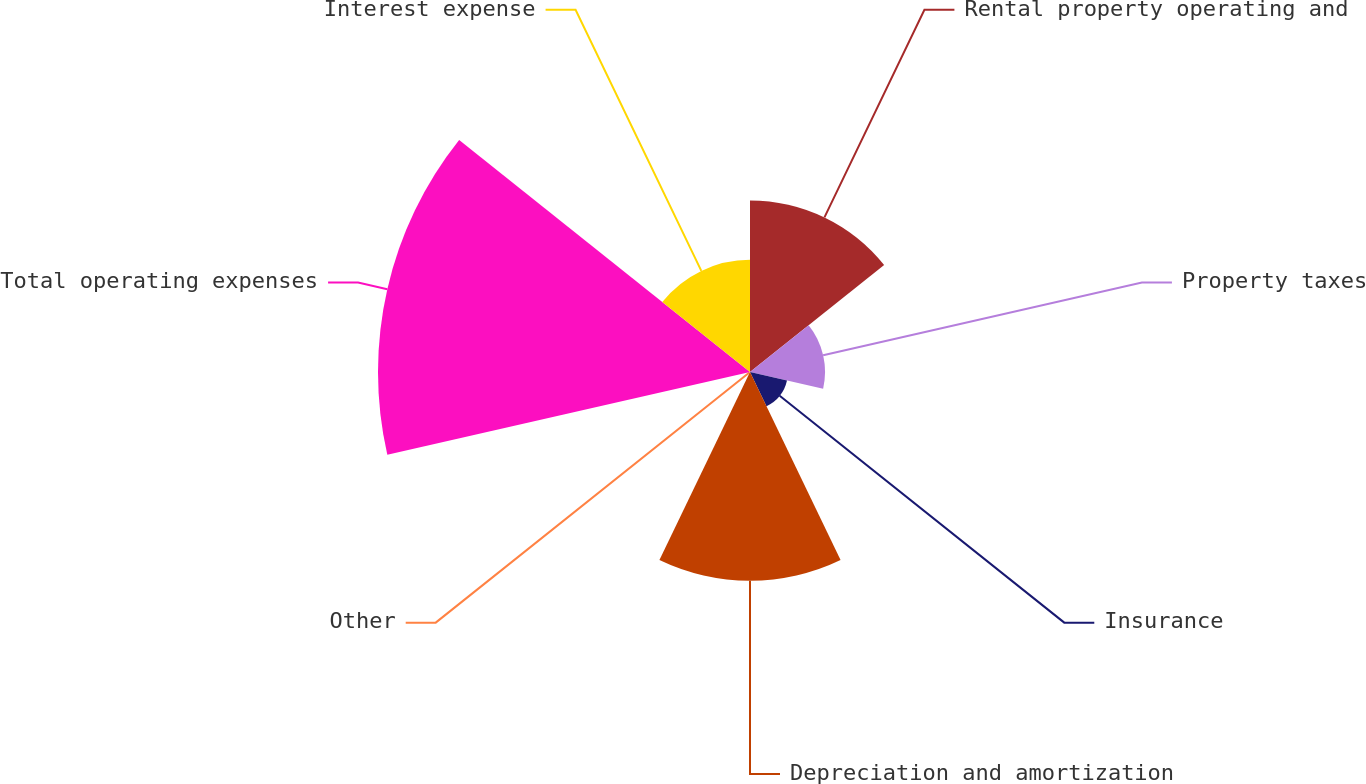Convert chart. <chart><loc_0><loc_0><loc_500><loc_500><pie_chart><fcel>Rental property operating and<fcel>Property taxes<fcel>Insurance<fcel>Depreciation and amortization<fcel>Other<fcel>Total operating expenses<fcel>Interest expense<nl><fcel>17.54%<fcel>7.67%<fcel>3.88%<fcel>21.34%<fcel>0.08%<fcel>38.03%<fcel>11.47%<nl></chart> 